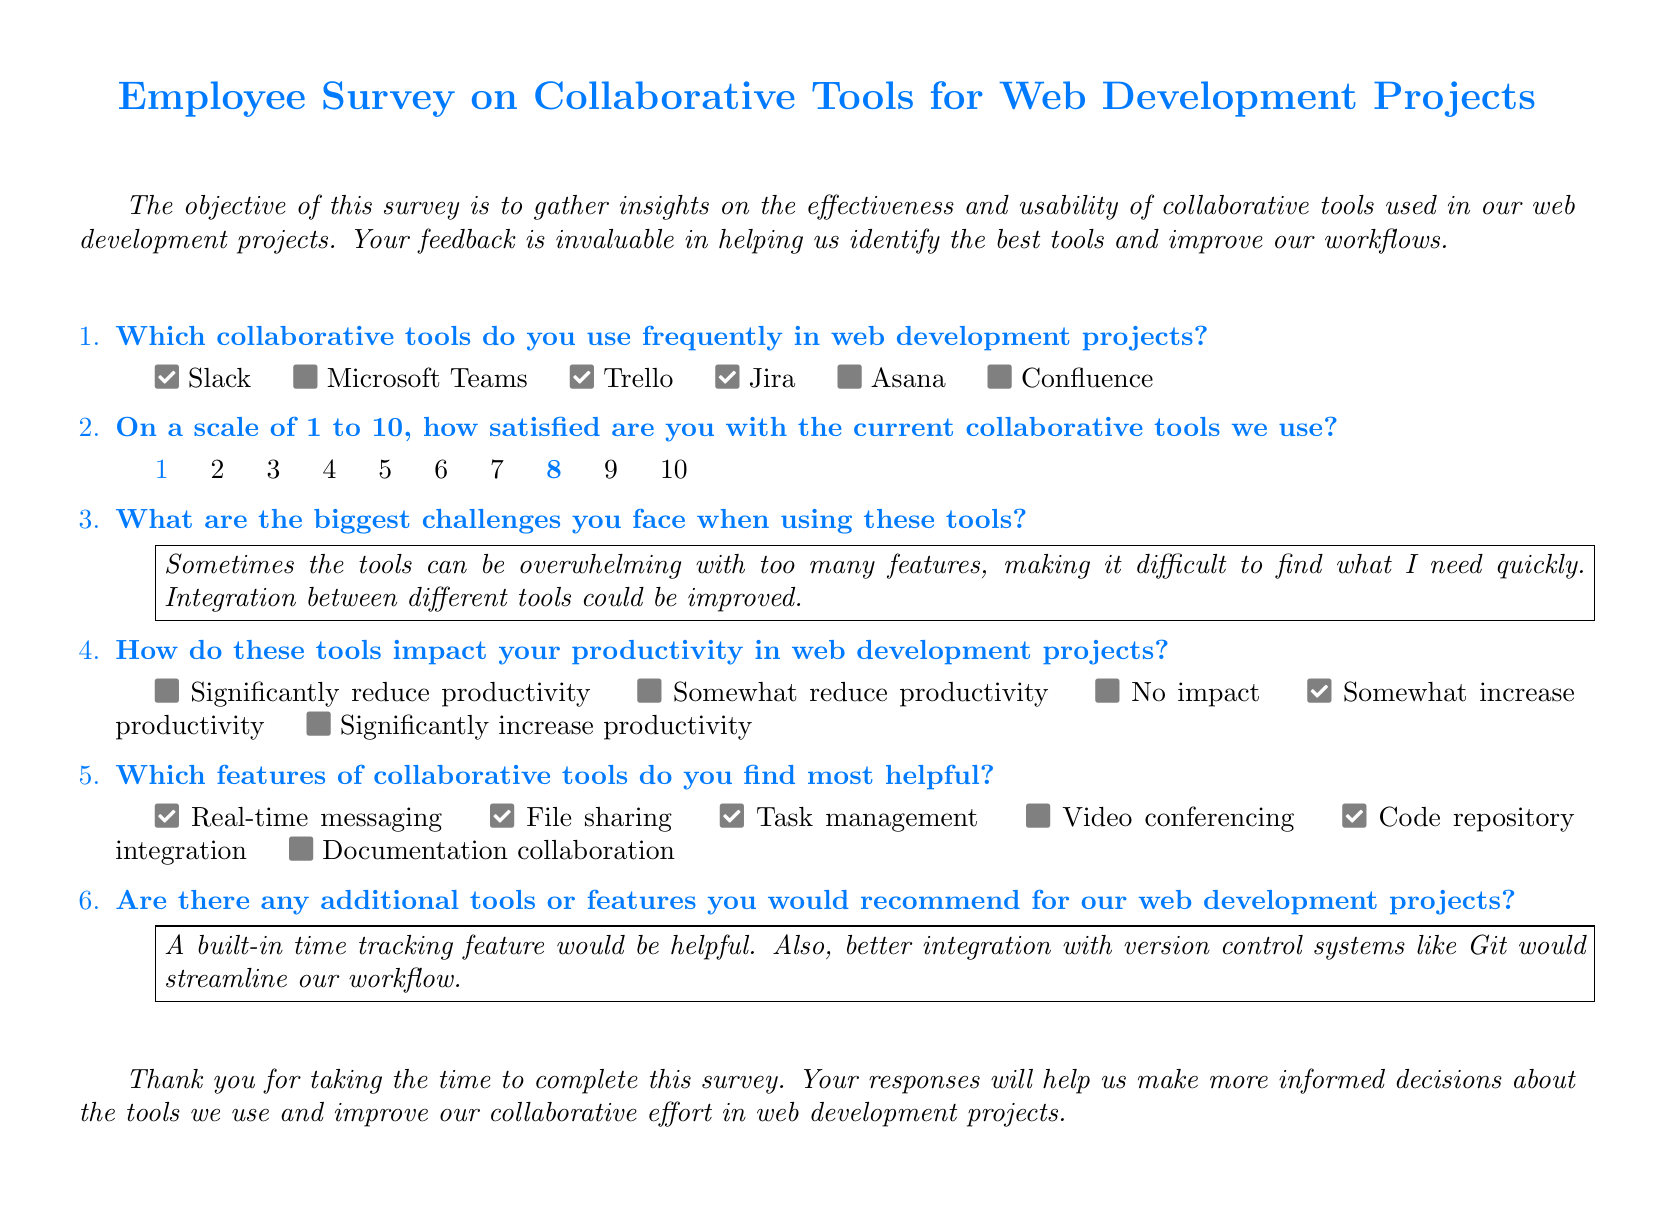Which collaborative tools are checked? The tools that are checked in the survey include Slack, Trello, and Jira.
Answer: Slack, Trello, Jira What is the satisfaction level rating checked by respondents? The rating checked by respondents is 8 on a scale of 1 to 10.
Answer: 8 What is one of the biggest challenges noted by respondents? Respondents noted that the tools can be overwhelming with too many features.
Answer: Overwhelming features How do the tools mostly impact productivity according to respondents? Respondents indicated that the tools somewhat increase productivity.
Answer: Somewhat increase productivity Which features are highlighted as most helpful? The features highlighted as most helpful include real-time messaging, file sharing, and task management.
Answer: Real-time messaging, file sharing, task management What additional tool feature is recommended? Respondents recommend a built-in time tracking feature.
Answer: Time tracking feature 